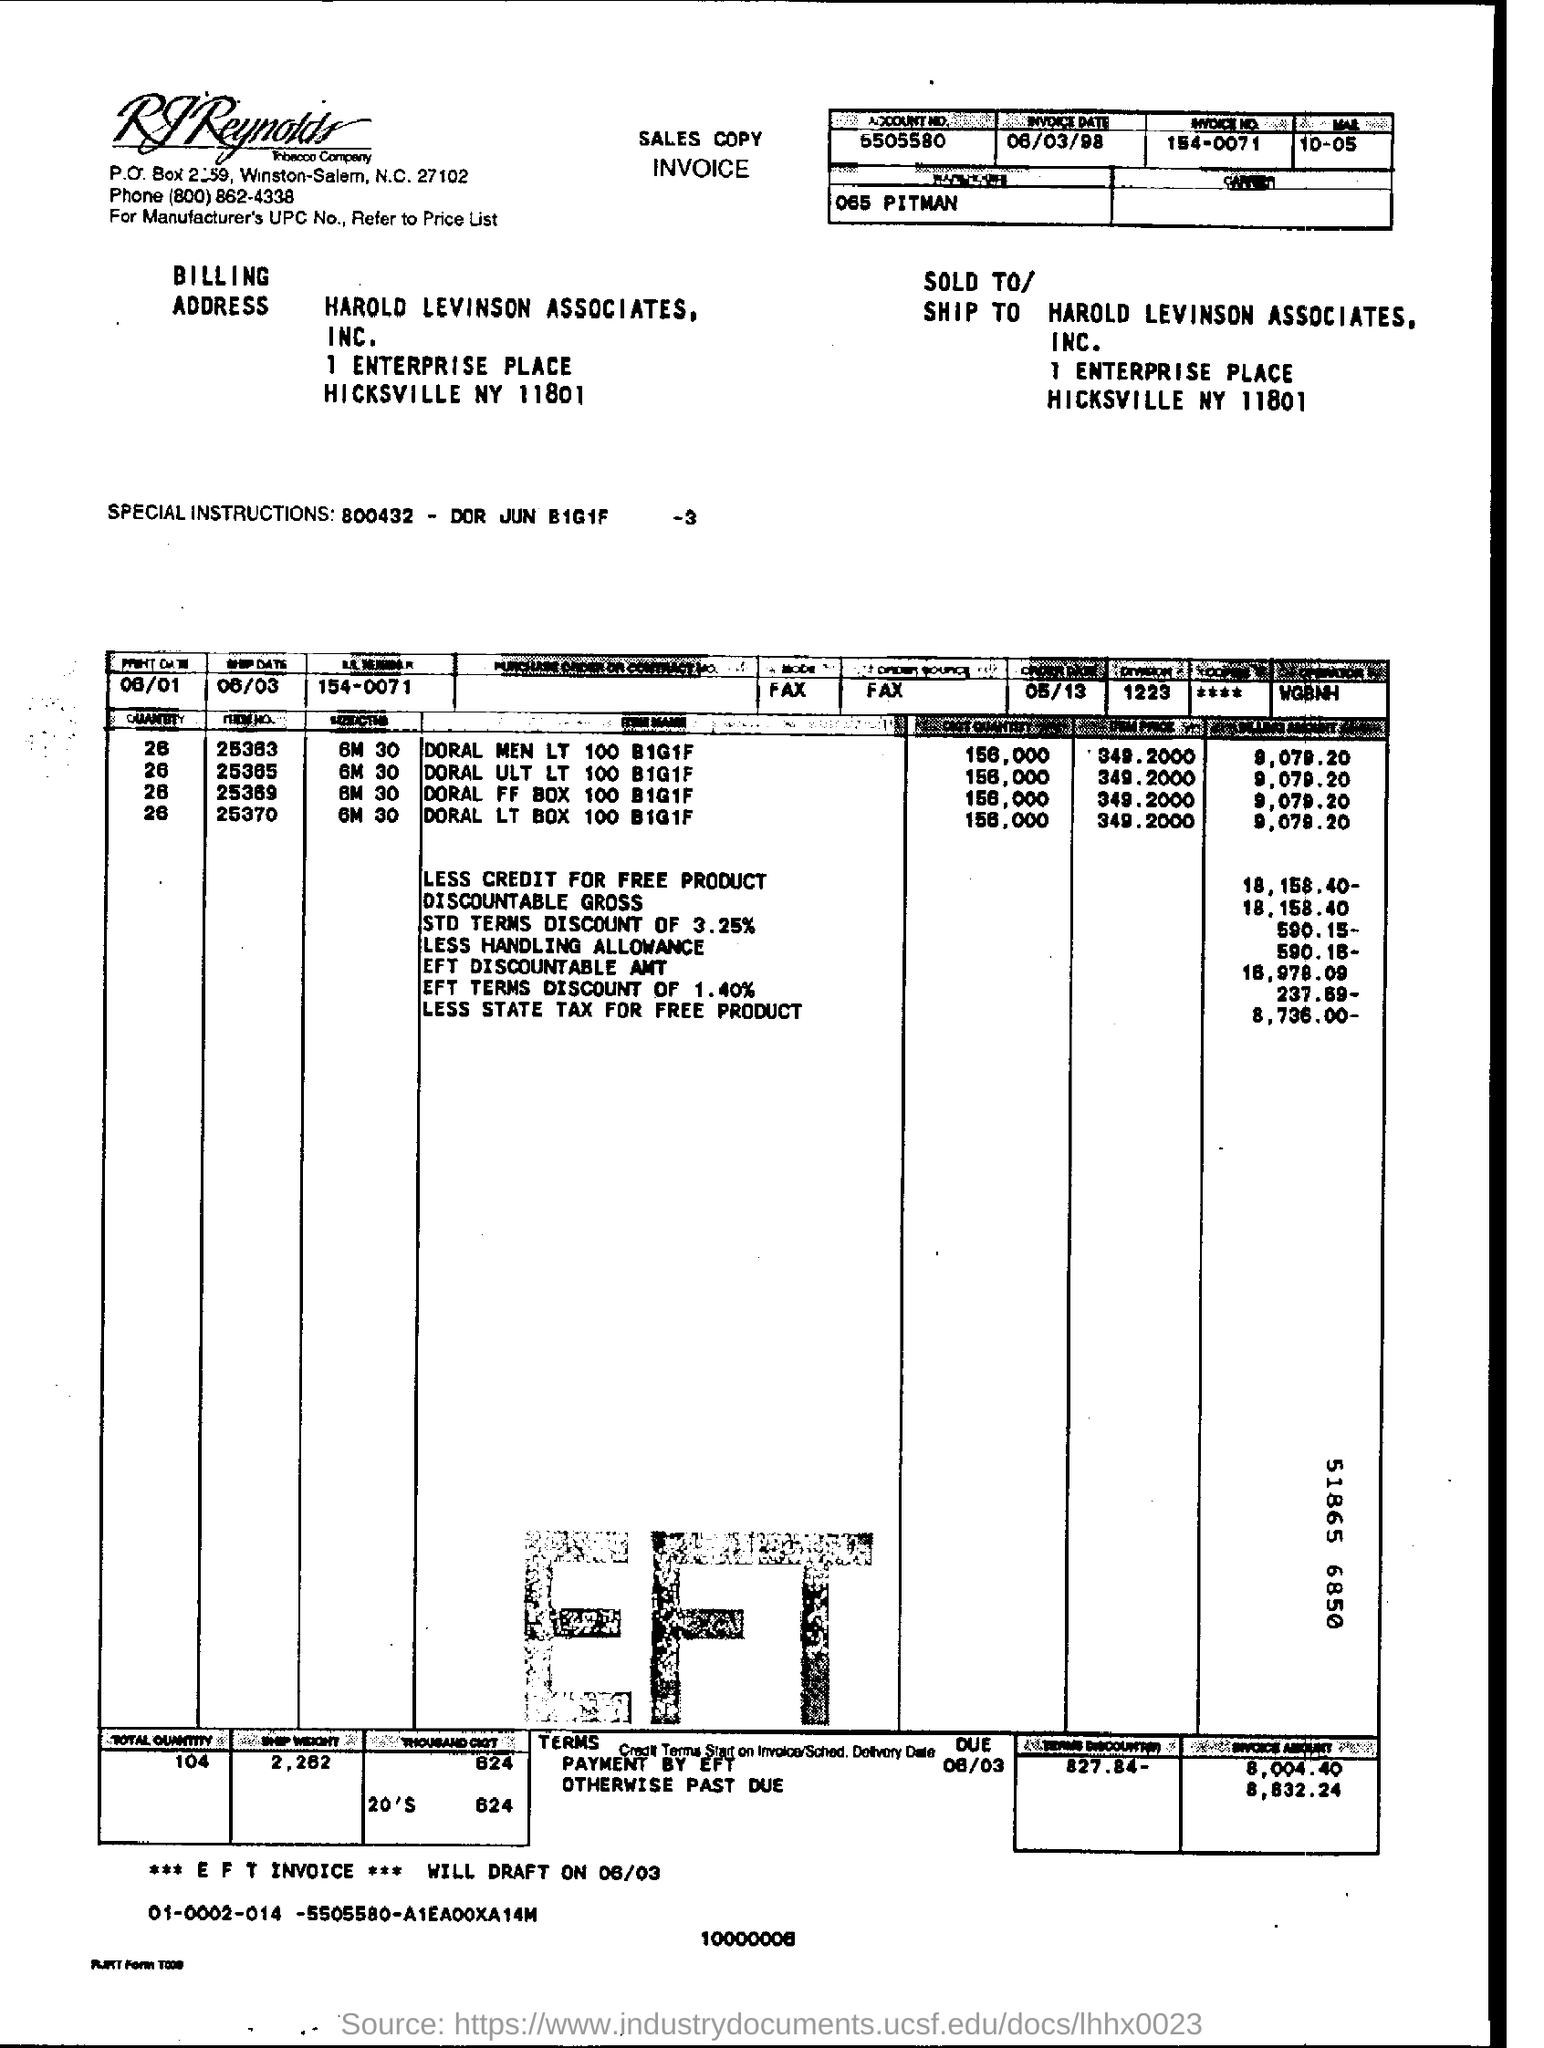Please provide the name and address of the billing company. The billing company's name is Harold Levinson Associates, Inc., and the address listed for billing is 1 Enterprise Place, Hicksville NY 11801. 